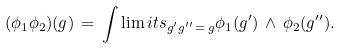Convert formula to latex. <formula><loc_0><loc_0><loc_500><loc_500>( \phi _ { 1 } \phi _ { 2 } ) ( g ) \, = \, \int \lim i t s _ { g ^ { \prime } g ^ { \prime \prime } \, = \, g } \phi _ { 1 } ( g ^ { \prime } ) \, \wedge \, \phi _ { 2 } ( g ^ { \prime \prime } ) .</formula> 